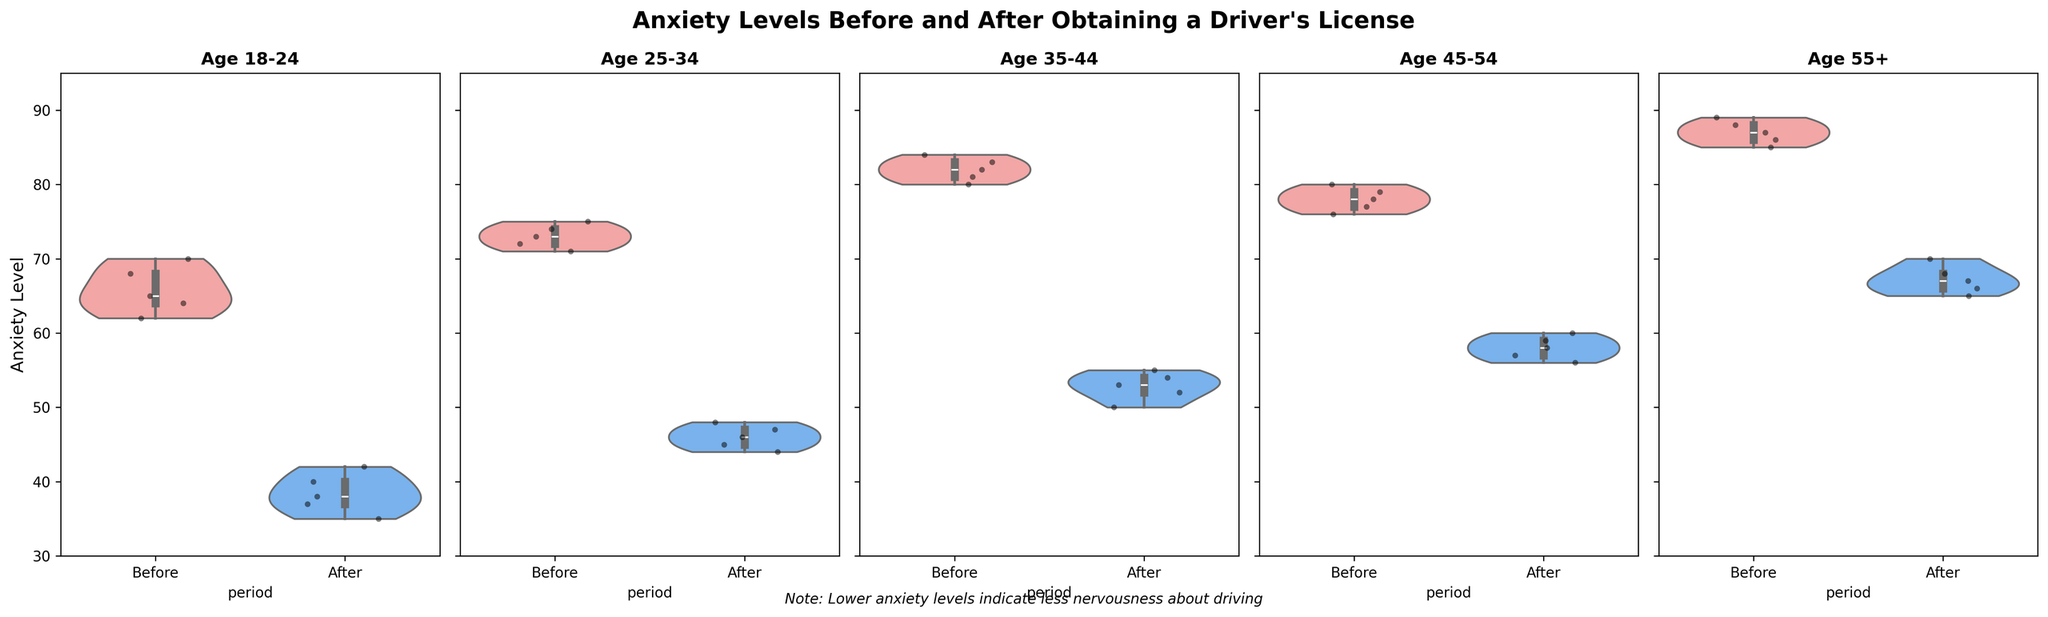What is the title of the figure? The title of the figure is displayed at the top in bold and larger font size. It reads "Anxiety Levels Before and After Obtaining a Driver's License".
Answer: "Anxiety Levels Before and After Obtaining a Driver's License" Which age group has the highest anxiety levels before obtaining a driver’s license? By inspecting the violin plots, you can see which age group has the highest distribution of anxiety levels before getting a driver’s license. For the age group 55+, the distribution shows higher values before obtaining a license compared to other groups.
Answer: 55+ Which period, ‘Before’ or ‘After’, has generally lower anxiety levels across all age groups? By looking at all the age groups, it is evident that the 'After' period shows a marked reduction in anxiety levels for each group compared to the 'Before' period. This can be seen as the lower part of the violins and the jittered points are lower for the 'After' period.
Answer: After What is the range of anxiety levels for the 18-24 age group after obtaining their license? For the 'After' period, observe the height and spread of the violin plot. The range can be found by identifying the minimum and maximum jittered points or the ends of the violin plot, which are between 35 and 42.
Answer: 35 to 42 Which age group exhibits the largest decrease in median anxiety levels after obtaining their license? To identify the largest decrease, compare the median lines inside the violin plots 'Before' and 'After' obtaining a license for each age group. The 35-44 age group shows the largest drop, where the median moves from around 82 to around 54.
Answer: 35-44 How do the anxiety levels of the 25-34 age group before obtaining their license compare with the 45-54 age group? Compare the height and central tendency of the violin plots for the 'Before' period for both age groups. The 25-34 age group has anxiety levels in the range of roughly 71-75, whereas the 45-54 age group ranges from around 76-80. The 45-54 group has slightly higher anxiety levels.
Answer: 45-54 group has higher anxiety levels What does the note at the bottom of the figure indicate? The note at the bottom of the figure is present to provide additional context. It states, "Note: Lower anxiety levels indicate less nervousness about driving," explaining that a lower number on the anxiety scale signifies reduced nervousness.
Answer: Lower anxiety levels indicate less nervousness about driving Which group has the smallest range of anxiety levels after obtaining their license? To find the smallest range, look at the spread of the 'After' period violin plots across all age groups. The 18-24 age group shows the narrowest range, approximately from 35 to 42.
Answer: 18-24 What is the median anxiety level for the 55+ age group before obtaining a license? To find the median, check the midpoint of the 'Before' period violin plot for the 55+ age group. The median line shows the value around 87.
Answer: 87 How does the distribution of anxiety levels change for the 45-54 age group from before to after obtaining their license? Compare the shape and range of the violin plots for the 'Before' and 'After' periods for the 45-54 age group. Anxiety decreases, with the distribution shifting from a range of roughly 76-80 before to approximately 56-60 after obtaining a license.
Answer: Anxiety decreases from 76-80 (before) to 56-60 (after) 